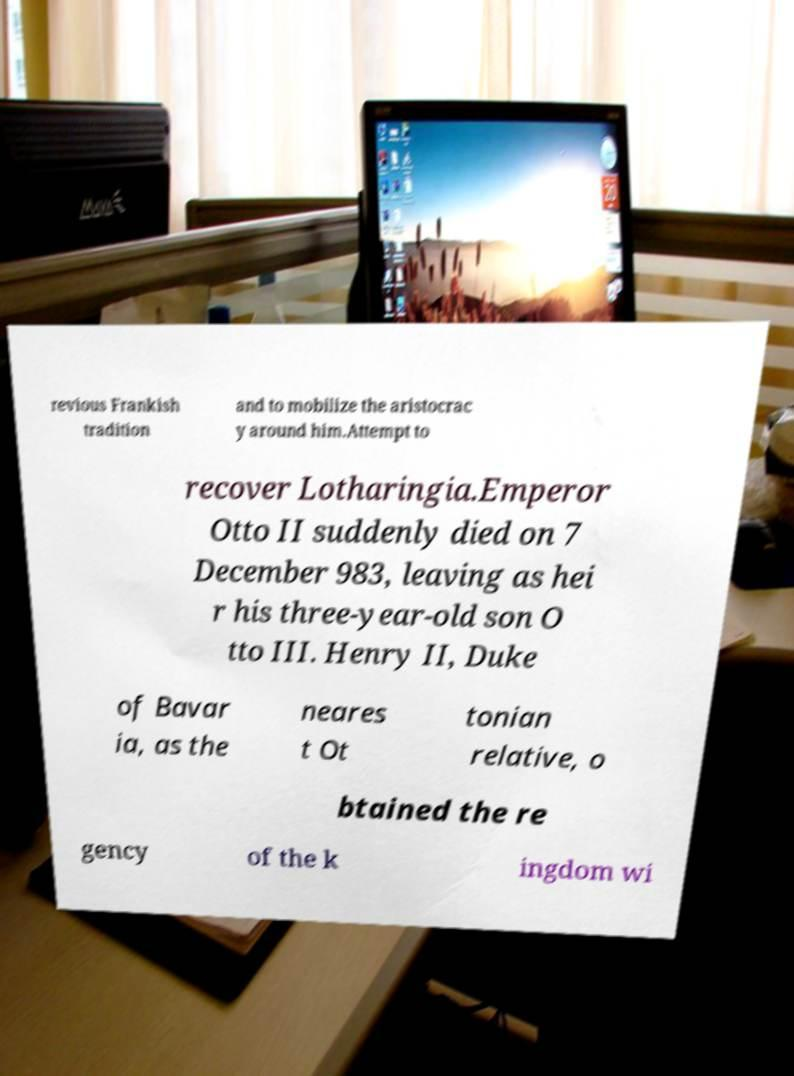Please read and relay the text visible in this image. What does it say? revious Frankish tradition and to mobilize the aristocrac y around him.Attempt to recover Lotharingia.Emperor Otto II suddenly died on 7 December 983, leaving as hei r his three-year-old son O tto III. Henry II, Duke of Bavar ia, as the neares t Ot tonian relative, o btained the re gency of the k ingdom wi 